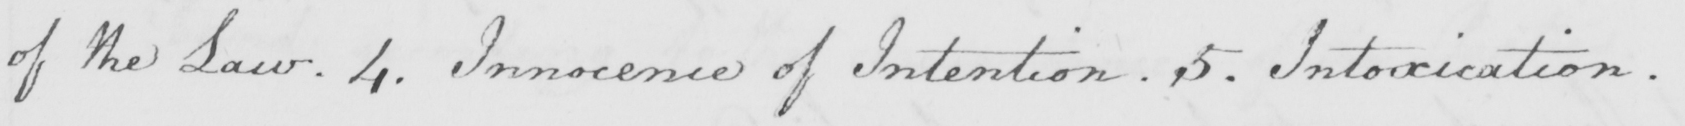Please transcribe the handwritten text in this image. of the Law . 4 . Innocence of Intention . 5 . Intoxication . 